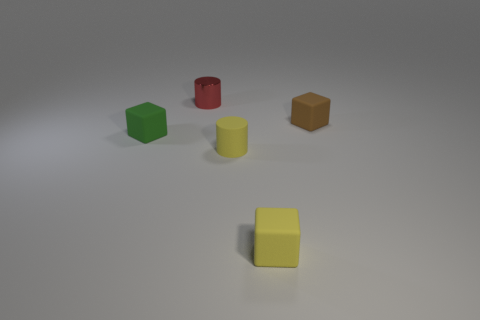Subtract all small green cubes. How many cubes are left? 2 Add 3 big cylinders. How many objects exist? 8 Subtract all yellow cylinders. How many cylinders are left? 1 Subtract all cylinders. How many objects are left? 3 Add 3 tiny cubes. How many tiny cubes are left? 6 Add 5 small yellow cylinders. How many small yellow cylinders exist? 6 Subtract 0 cyan spheres. How many objects are left? 5 Subtract 1 cylinders. How many cylinders are left? 1 Subtract all green cylinders. Subtract all cyan cubes. How many cylinders are left? 2 Subtract all tiny purple rubber objects. Subtract all tiny green things. How many objects are left? 4 